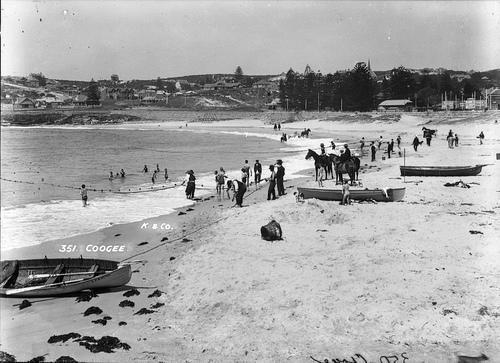How many cars are in the parking lot?
Give a very brief answer. 0. 